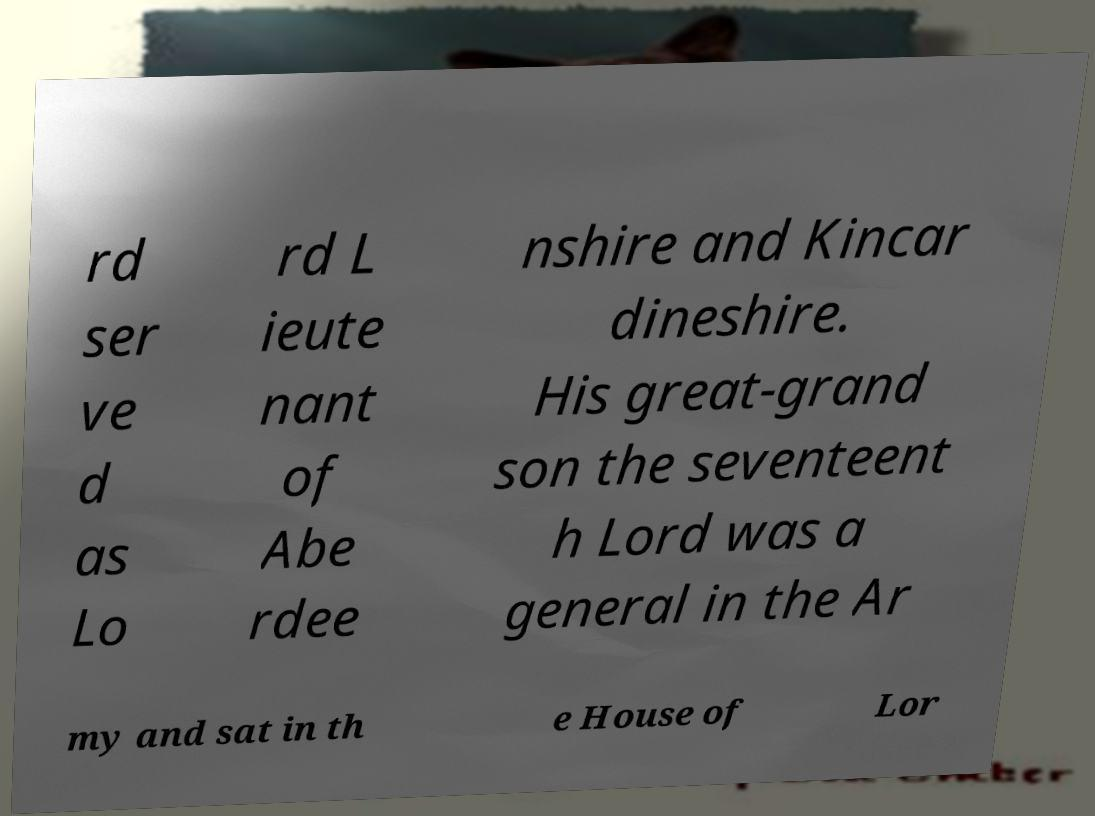What messages or text are displayed in this image? I need them in a readable, typed format. rd ser ve d as Lo rd L ieute nant of Abe rdee nshire and Kincar dineshire. His great-grand son the seventeent h Lord was a general in the Ar my and sat in th e House of Lor 